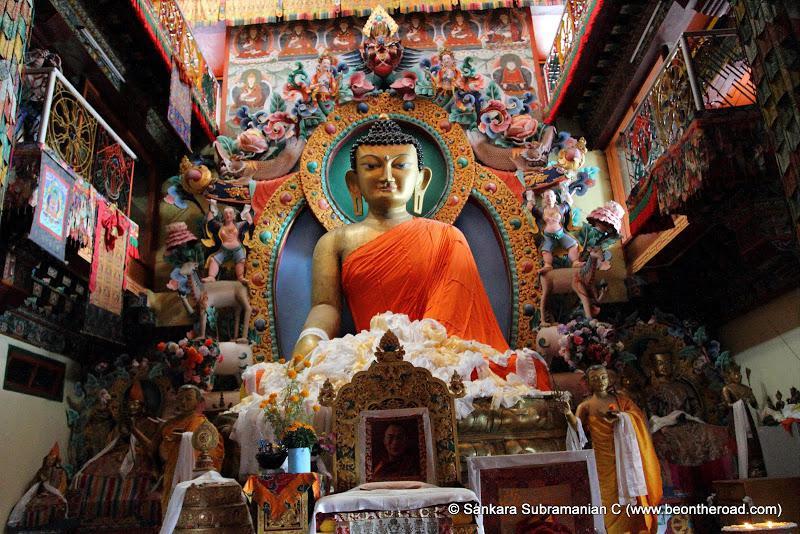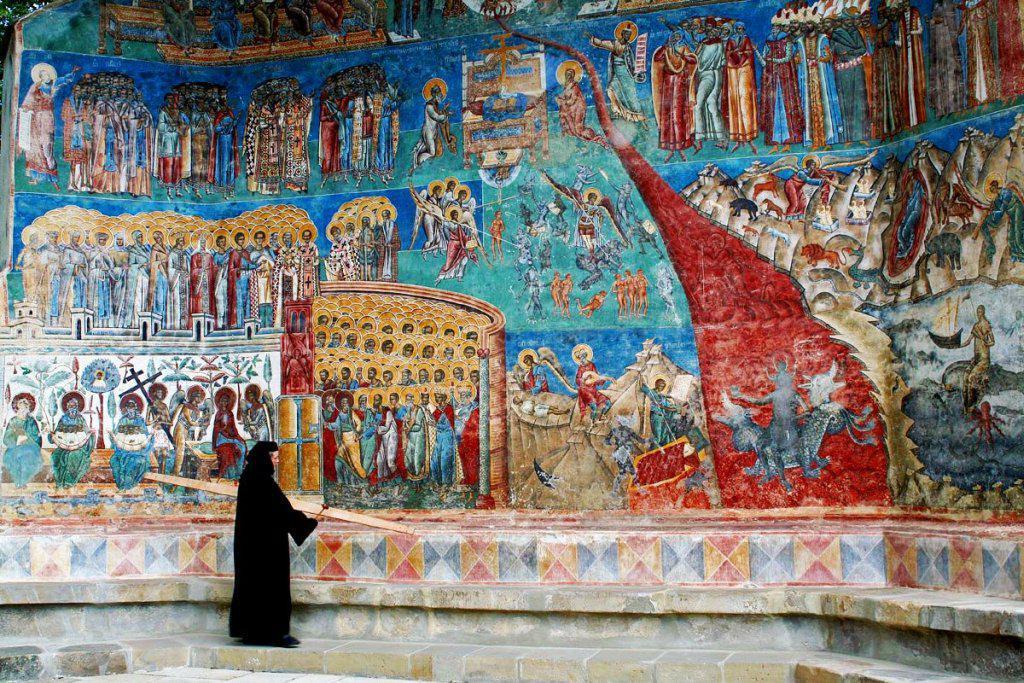The first image is the image on the left, the second image is the image on the right. Analyze the images presented: Is the assertion "There are three religious statues in the left image." valid? Answer yes or no. No. The first image is the image on the left, the second image is the image on the right. Assess this claim about the two images: "The left image features three gold figures in lotus positions side-by-side in a row, with the figures on the ends wearing crowns.". Correct or not? Answer yes or no. No. 